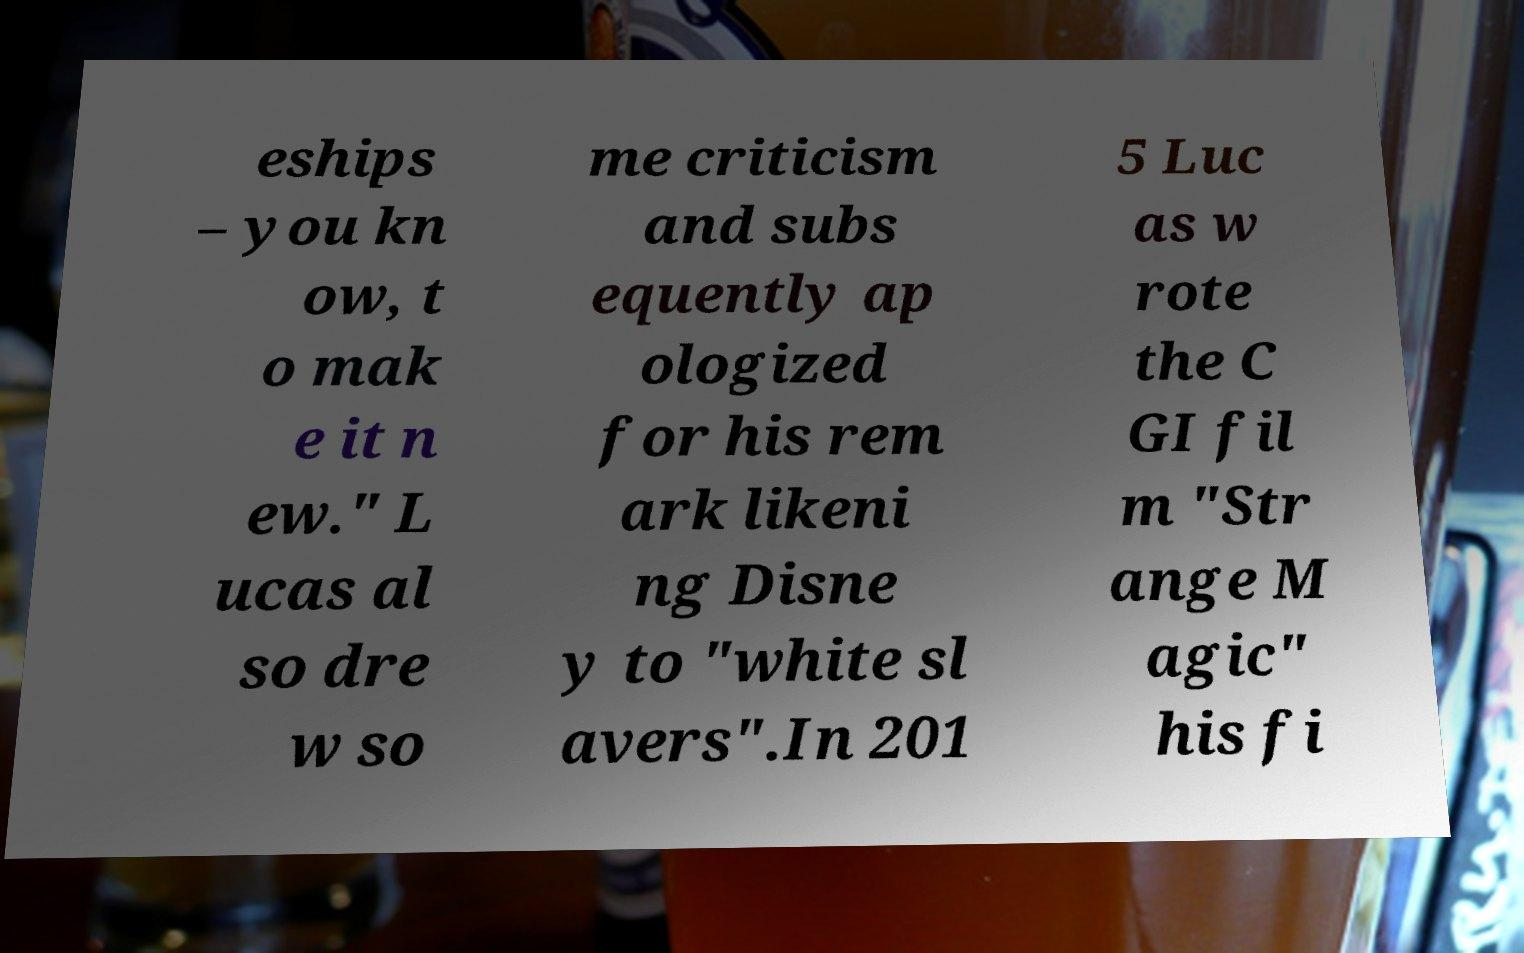What messages or text are displayed in this image? I need them in a readable, typed format. eships – you kn ow, t o mak e it n ew." L ucas al so dre w so me criticism and subs equently ap ologized for his rem ark likeni ng Disne y to "white sl avers".In 201 5 Luc as w rote the C GI fil m "Str ange M agic" his fi 